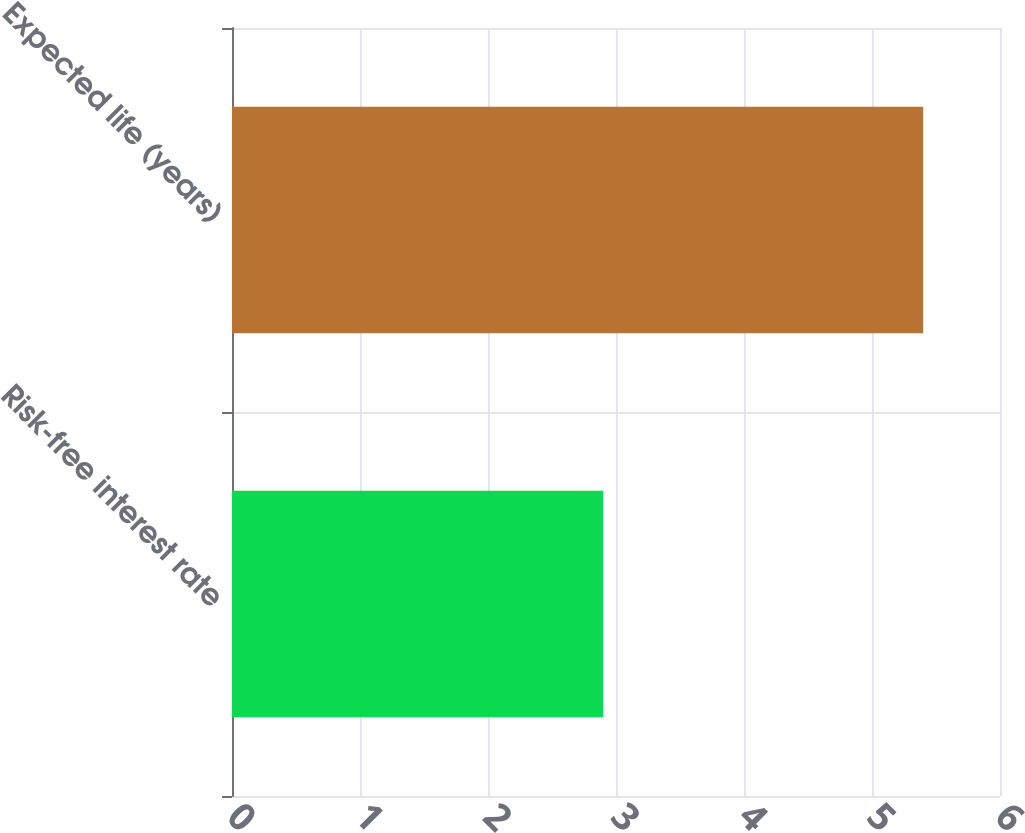<chart> <loc_0><loc_0><loc_500><loc_500><bar_chart><fcel>Risk-free interest rate<fcel>Expected life (years)<nl><fcel>2.9<fcel>5.4<nl></chart> 